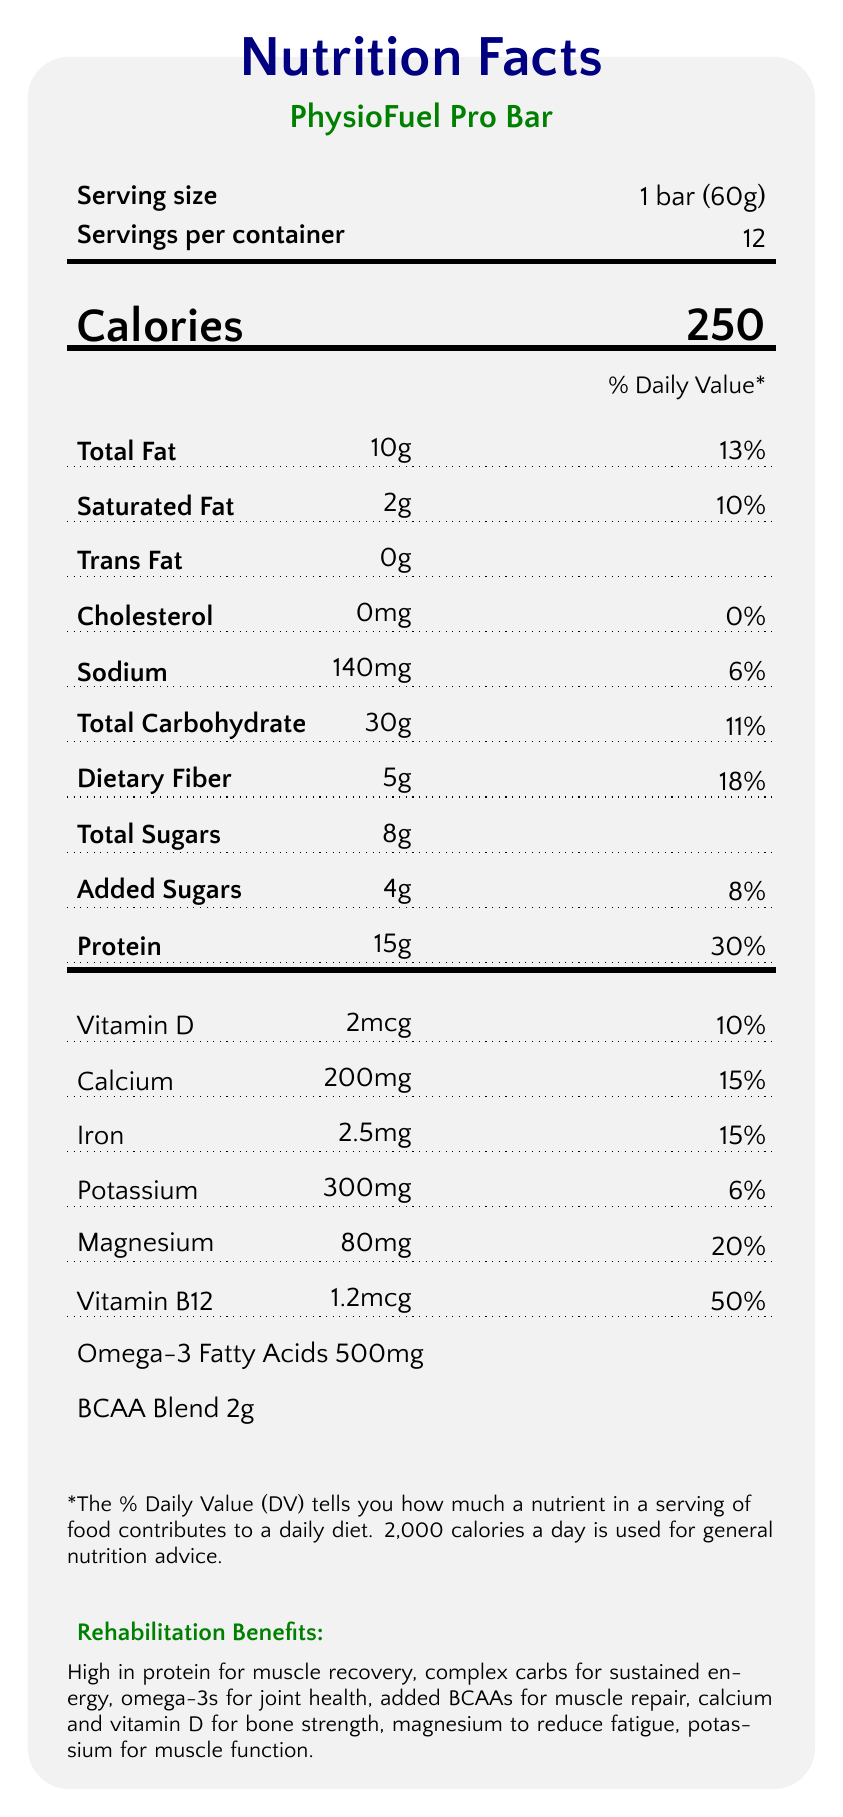what is the serving size? The serving size is explicitly listed as 1 bar (60g) in the serving information section of the Nutrition Facts Label.
Answer: 1 bar (60g) how many calories are in one serving? The number of calories per serving is clearly stated as 250 in large font under the calories section.
Answer: 250 how much protein does one bar contain? The protein content per bar is listed as 15g in the nutrient lines section.
Answer: 15g what is the daily value percentage for dietary fiber? The daily value percentage for dietary fiber is given as 18% in the dietary fiber section.
Answer: 18% which nutrients have a 0% daily value? The cholesterol section shows both the amount (0mg) and the daily value percentage (0%) for this nutrient.
Answer: Cholesterol where should the PhysioFuel Pro Bar be stored? The storage instructions specify that the bar should be stored in a cool, dry place.
Answer: In a cool, dry place how many servings are in one container? The document states that there are 12 servings per container.
Answer: 12 which ingredient in PhysioFuel Pro Bar is a source of omega-3 fatty acids? Chia seeds are listed among the ingredients and are known to be a source of omega-3 fatty acids.
Answer: Chia seeds how much added sugar is in one bar? The amount of added sugars is indicated as 4g in the nutrient details.
Answer: 4g what are the rehabilitation benefits of consuming this energy bar? The document lists several rehabilitation benefits: high in protein for muscle recovery, complex carbs for sustained energy, omega-3s for joint health, added BCAAs for muscle repair, calcium and vitamin D for bone strength, magnesium to reduce fatigue, and potassium for muscle function.
Answer: Muscle recovery, sustained energy, joint health, muscle repair, bone strength, reduced muscle fatigue how much calcium does one bar provide? The calcium content is specified as 200mg in the vitamins and minerals section.
Answer: 200mg which nutrient contributes the highest percentage to the daily value? A. Vitamin D B. Vitamin B12 C. Magnesium Vitamin B12 contributes 50% to the daily value, which is higher than the other listed nutrients.
Answer: B which ingredient is NOT part of PhysioFuel Pro Bar? A. Flaxseed B. Almond butter C. Soy protein D. Cocoa powder Soy protein is not listed among the ingredients; instead, pea protein appears in the ingredients list.
Answer: C does the PhysioFuel Pro Bar contain any trans fat? The document clearly shows that the trans fat amount is 0g.
Answer: No summarize the main idea of the nutrition facts label The label describes the nutrient content per serving, including calories, fats, proteins, carbohydrates, vitamins, and minerals. It emphasizes the bar's benefits for rehabilitation, including muscle repair, energy provision, and bone strength, along with specific allergy and storage instructions.
Answer: The Nutrition Facts Label for PhysioFuel Pro Bar provides detailed information about the serving size, caloric content, and nutrient composition, including macronutrients, vitamins, and minerals. It specifically highlights the rehabilitation benefits of the bar, which include muscle recovery, sustained energy, and bone and joint health, making it suitable for patients undergoing intensive physical therapy. Allergy and storage information is also provided. how much beta-carotene does one bar contain? The document does not provide any information regarding the content of beta-carotene.
Answer: Not enough information 